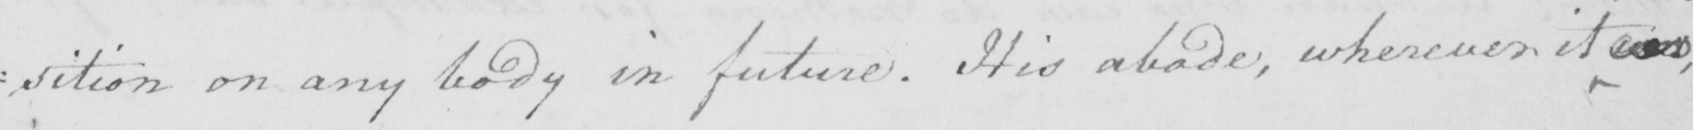Transcribe the text shown in this historical manuscript line. : sition on any body in future . His abode , wherever it was , 